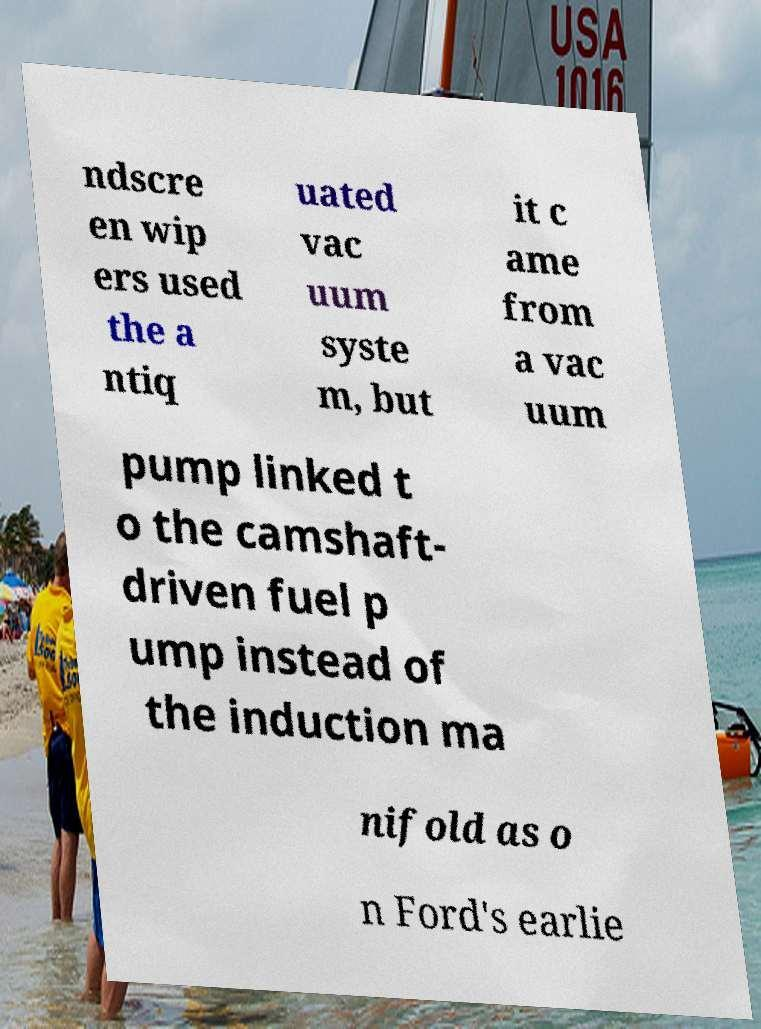For documentation purposes, I need the text within this image transcribed. Could you provide that? ndscre en wip ers used the a ntiq uated vac uum syste m, but it c ame from a vac uum pump linked t o the camshaft- driven fuel p ump instead of the induction ma nifold as o n Ford's earlie 